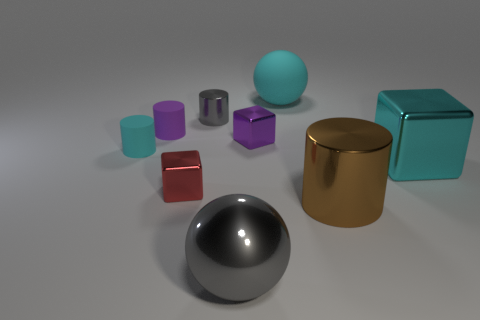Does the cyan object on the left side of the big gray shiny thing have the same size as the gray object that is in front of the tiny purple rubber object?
Give a very brief answer. No. What number of metallic things are in front of the large metal block and on the right side of the small gray object?
Offer a terse response. 2. What color is the other big thing that is the same shape as the red shiny thing?
Offer a terse response. Cyan. Are there fewer small brown metallic things than red shiny blocks?
Provide a succinct answer. Yes. Is the size of the purple matte cylinder the same as the metallic block behind the large cyan cube?
Your answer should be compact. Yes. What color is the shiny object in front of the big brown object that is in front of the tiny cyan matte cylinder?
Provide a succinct answer. Gray. How many things are big shiny blocks that are right of the tiny purple rubber thing or big cyan rubber spheres that are right of the tiny gray metal thing?
Offer a terse response. 2. Is the size of the cyan cylinder the same as the brown metal object?
Your answer should be very brief. No. Do the big rubber object behind the big metallic cylinder and the gray object that is in front of the small purple rubber object have the same shape?
Offer a terse response. Yes. How big is the cyan ball?
Make the answer very short. Large. 